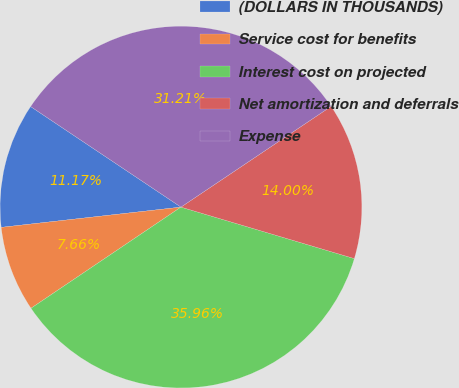<chart> <loc_0><loc_0><loc_500><loc_500><pie_chart><fcel>(DOLLARS IN THOUSANDS)<fcel>Service cost for benefits<fcel>Interest cost on projected<fcel>Net amortization and deferrals<fcel>Expense<nl><fcel>11.17%<fcel>7.66%<fcel>35.96%<fcel>14.0%<fcel>31.21%<nl></chart> 